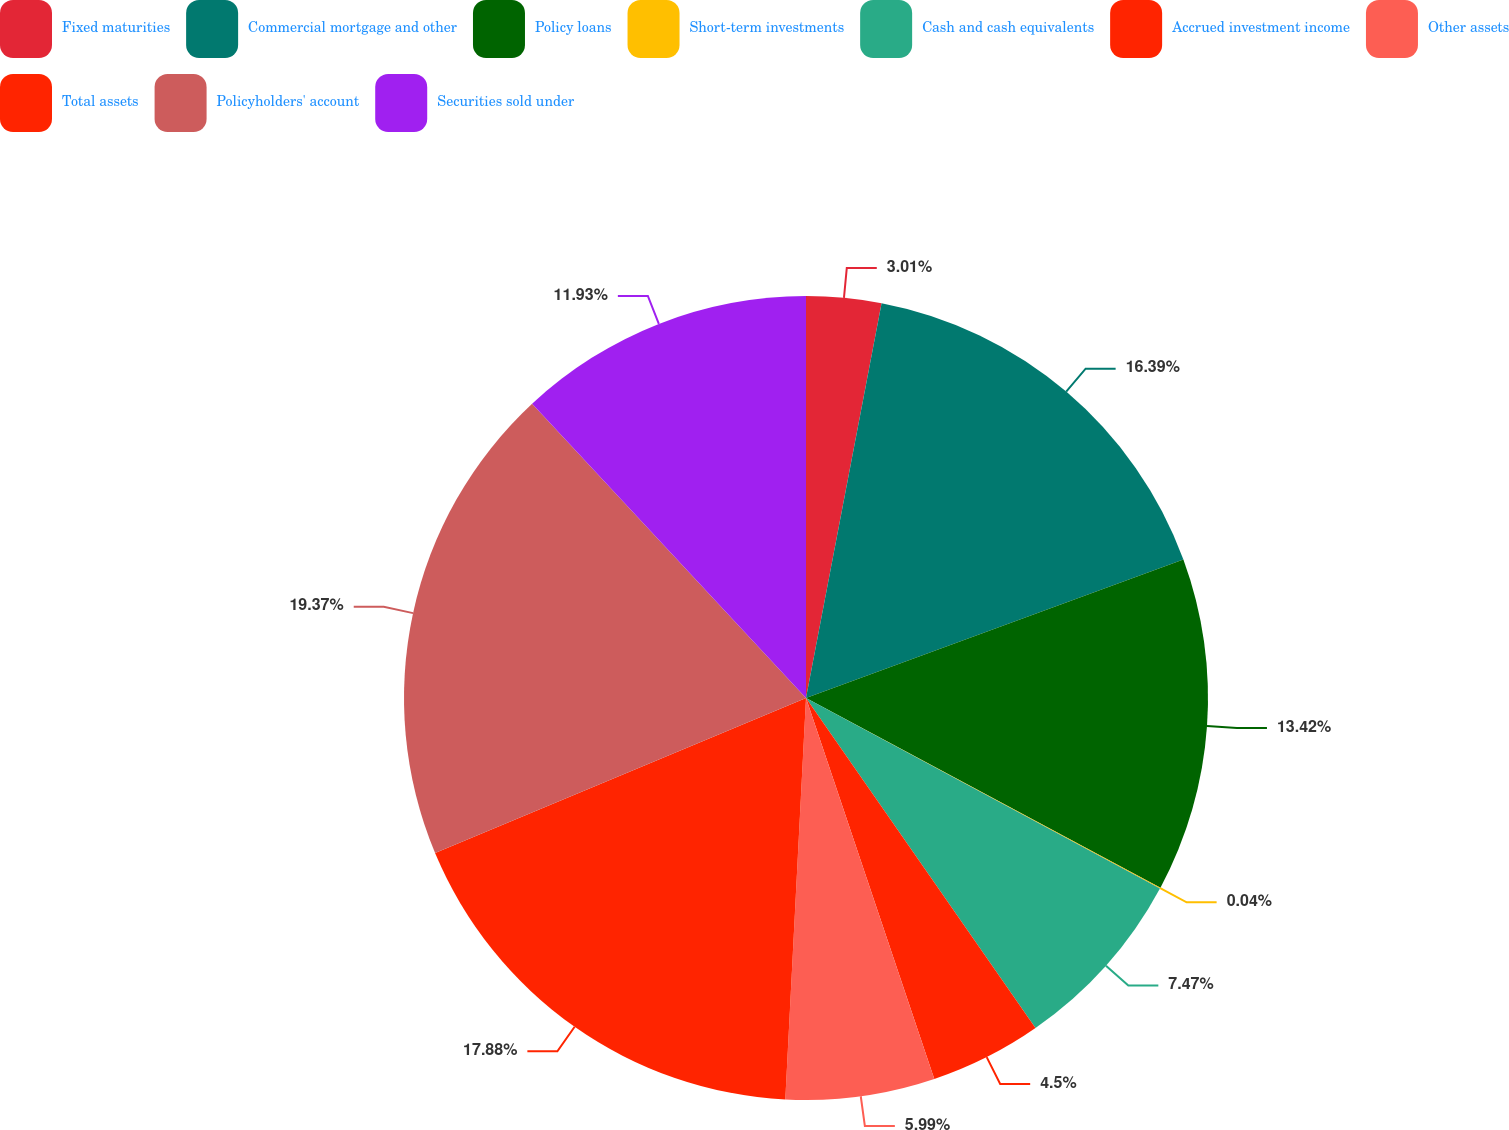<chart> <loc_0><loc_0><loc_500><loc_500><pie_chart><fcel>Fixed maturities<fcel>Commercial mortgage and other<fcel>Policy loans<fcel>Short-term investments<fcel>Cash and cash equivalents<fcel>Accrued investment income<fcel>Other assets<fcel>Total assets<fcel>Policyholders' account<fcel>Securities sold under<nl><fcel>3.01%<fcel>16.39%<fcel>13.42%<fcel>0.04%<fcel>7.47%<fcel>4.5%<fcel>5.99%<fcel>17.88%<fcel>19.37%<fcel>11.93%<nl></chart> 